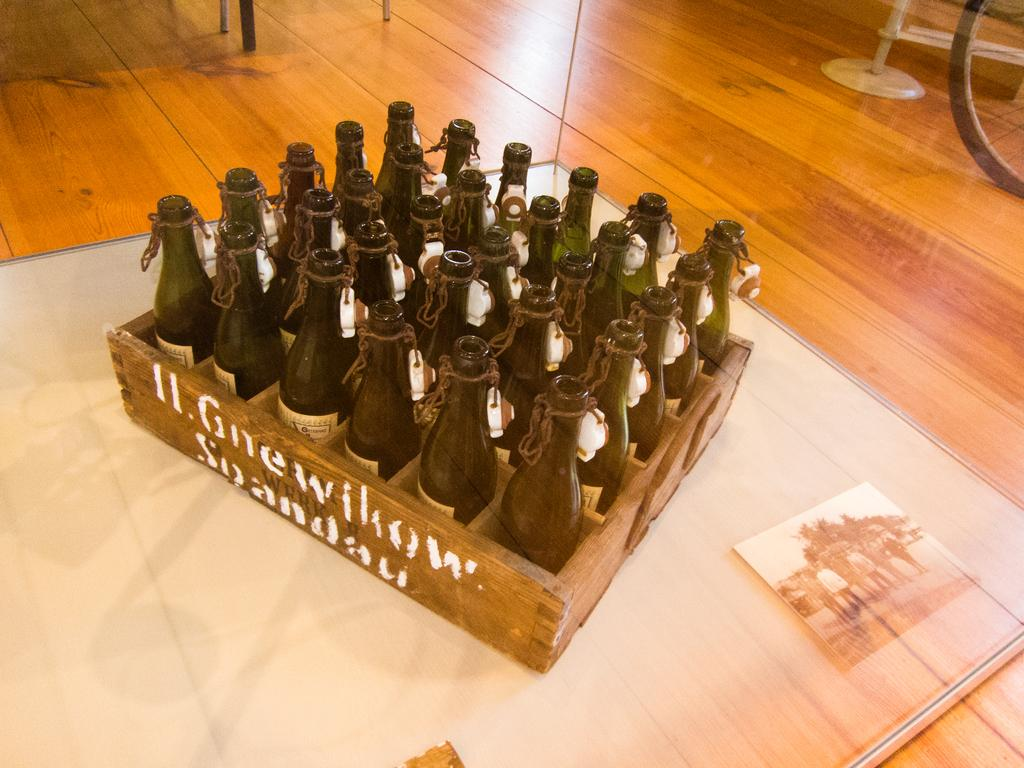<image>
Write a terse but informative summary of the picture. An old crate labeled Gnewillow is filled with empty bottles. 